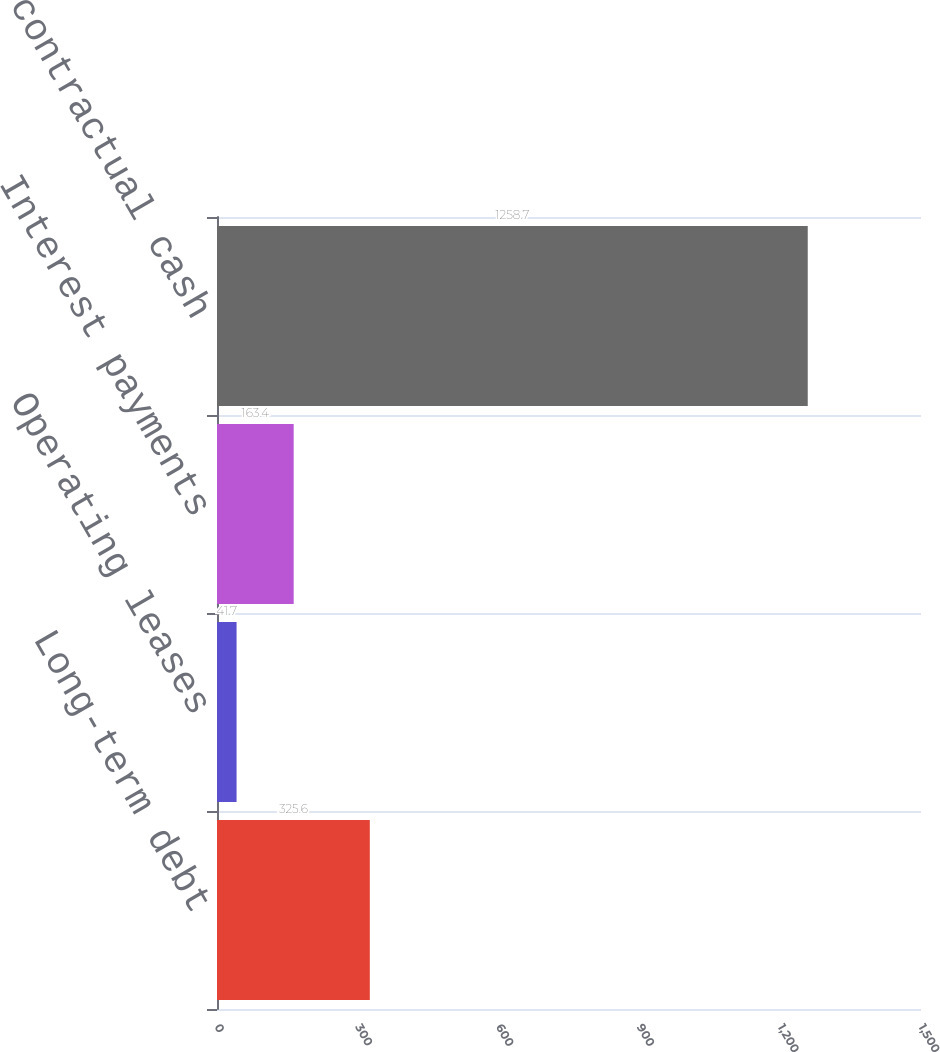<chart> <loc_0><loc_0><loc_500><loc_500><bar_chart><fcel>Long-term debt<fcel>Operating leases<fcel>Interest payments<fcel>Total contractual cash<nl><fcel>325.6<fcel>41.7<fcel>163.4<fcel>1258.7<nl></chart> 